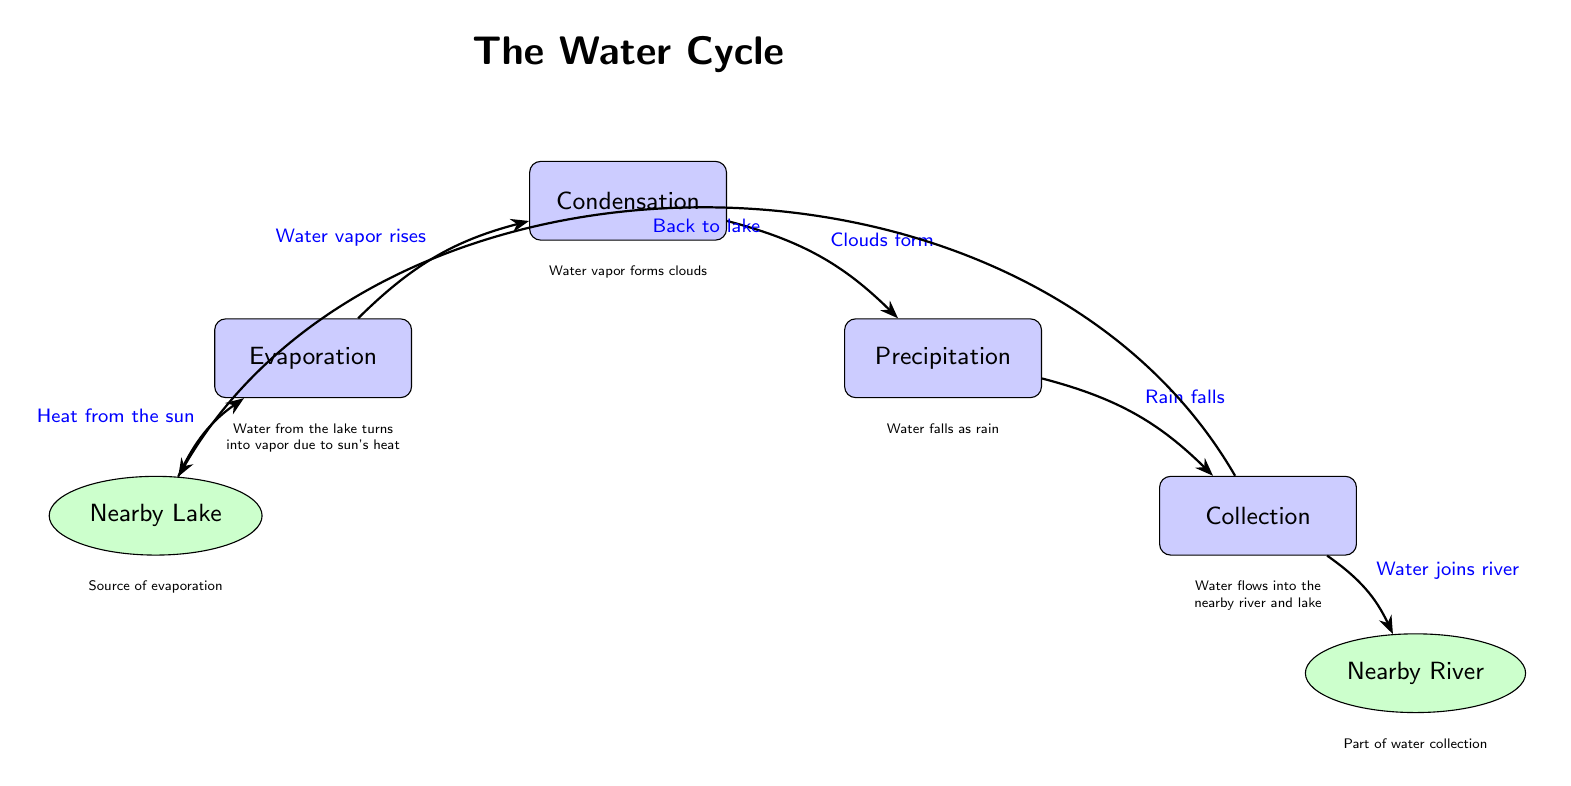What are the four stages of the water cycle depicted in the diagram? The diagram specifically labels the stages as Evaporation, Condensation, Precipitation, and Collection. Therefore, by simply listing these four terms stated directly in the nodes, we can answer the question.
Answer: Evaporation, Condensation, Precipitation, Collection What is the first process in the water cycle illustrated? The diagram indicates that the process at the starting point is labeled as Evaporation. Thus, identifying the first process from the leftmost node allows us to answer the question directly based on its placement in the flow.
Answer: Evaporation How does water vapor reach the next stage after evaporation? The diagram shows a directed arrow from the Evaporation node to the Condensation node, indicating the progression of water vapor rising to this next stage. Reading the labeled arrow also provides clarity on this transition.
Answer: Water vapor rises How does precipitation occur in the water cycle? In the diagram, precipitation is described as occurring when clouds form, which is detailed in the arrow leading from the Condensation node to the Precipitation node. Thus, by following this path and the explanation provided in the diagram, we identify the process of precipitation.
Answer: Rain falls What happens to water after it collects in the collection stage? The diagram shows an arrow leading from the Collection node to the Nearby River, indicating that collected water flows into it. Therefore, by following this directed edge, we can identify what occurs after water is collected.
Answer: Water joins river How many natural elements are depicted in the diagram? There are two natural elements shown in the diagram; they are the Nearby Lake and the Nearby River. Counting the nodes labeled as nature allows us to arrive at this answer effectively.
Answer: 2 What is the source of evaporation in this diagram? The diagram specifies that the Nearby Lake is the source of evaporation, as indicated by the direct connection with an arrow from this node to the Evaporation process node. Hence, this interpretation allows us to provide a clear answer.
Answer: Nearby Lake What drives the evaporation process according to the diagram? The diagram states that evaporation is driven by "Heat from the sun," as noted on the arrow leading into the Evaporation node. Thus, we can conclude that the cause of evaporation is accurately represented in this labeled relationship.
Answer: Heat from the sun What are the two end points represented in the diagram? The diagram shows two endpoints, which are the Nearby Lake and the Nearby River. Identifying these nodes at either end of the process flow indicates that these are the destinations of the water cycle’s output.
Answer: Nearby Lake, Nearby River 